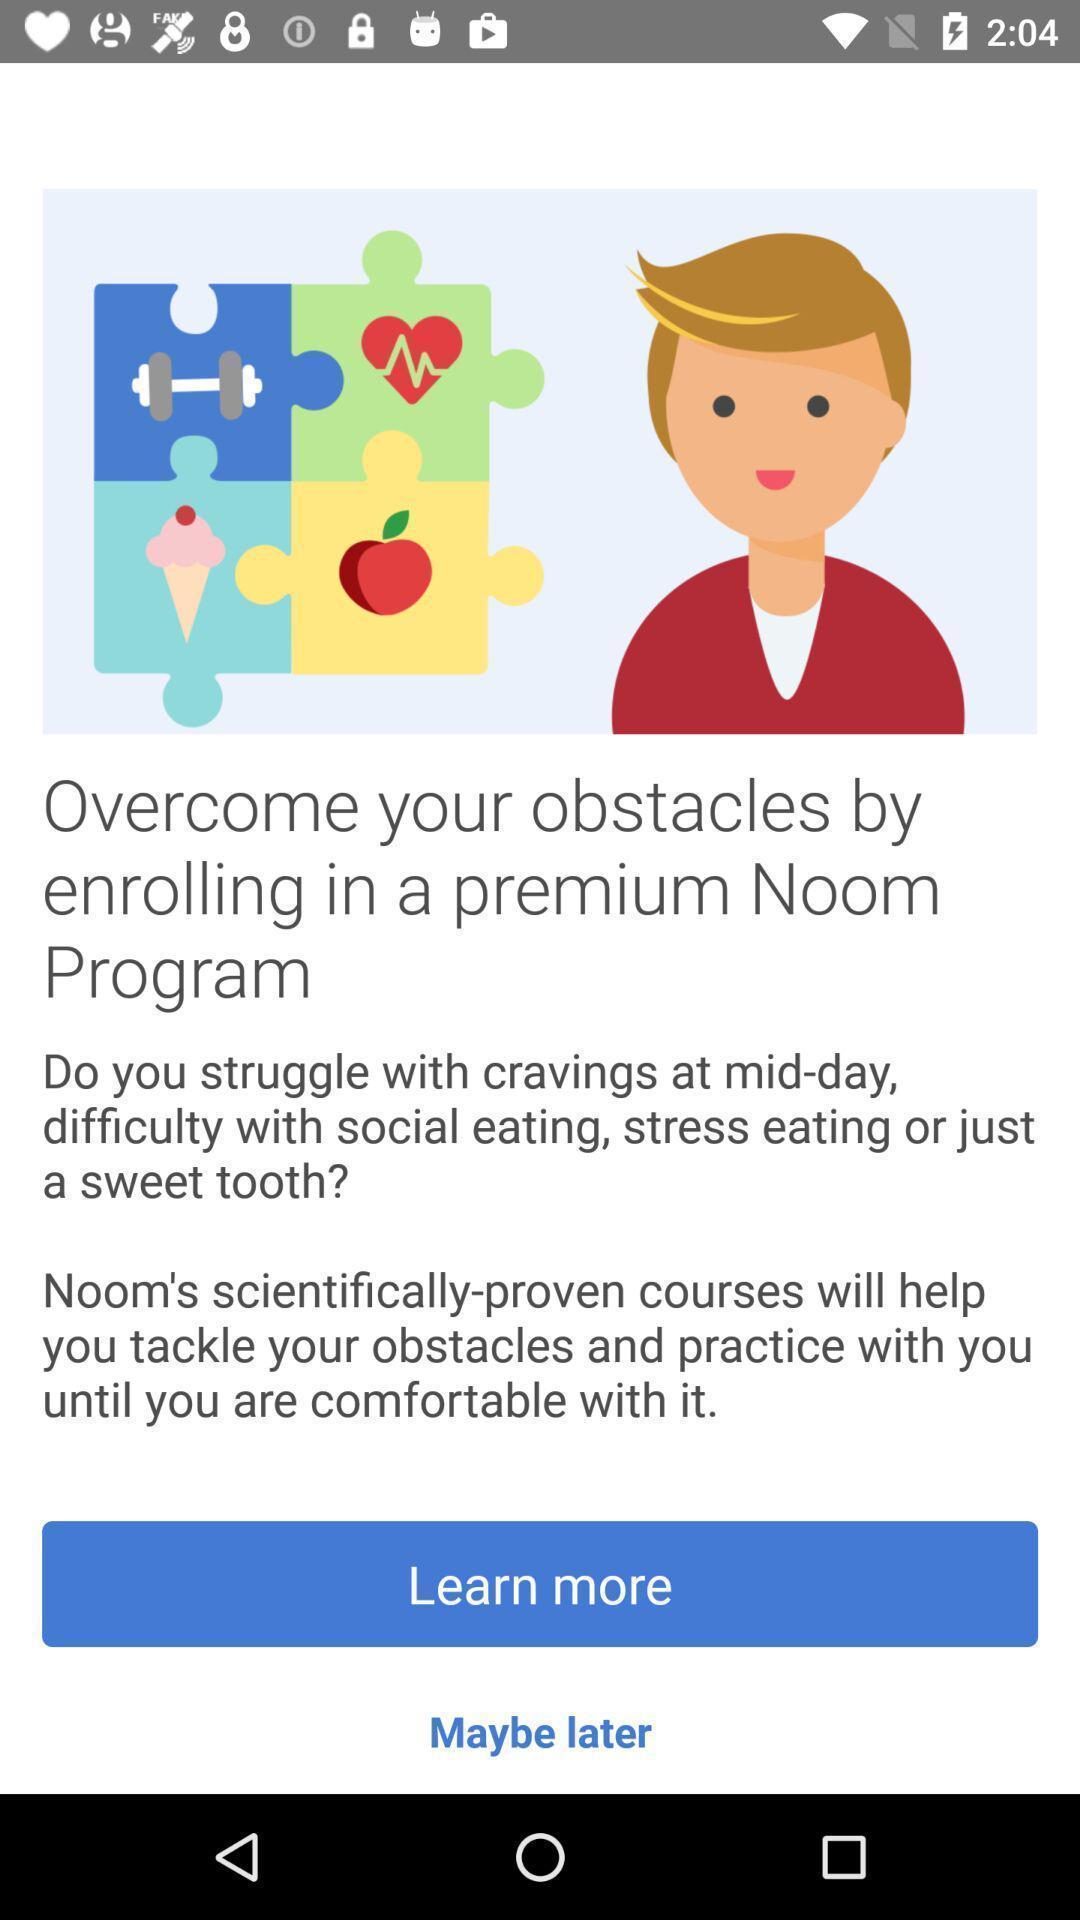Provide a detailed account of this screenshot. Welcome page. 